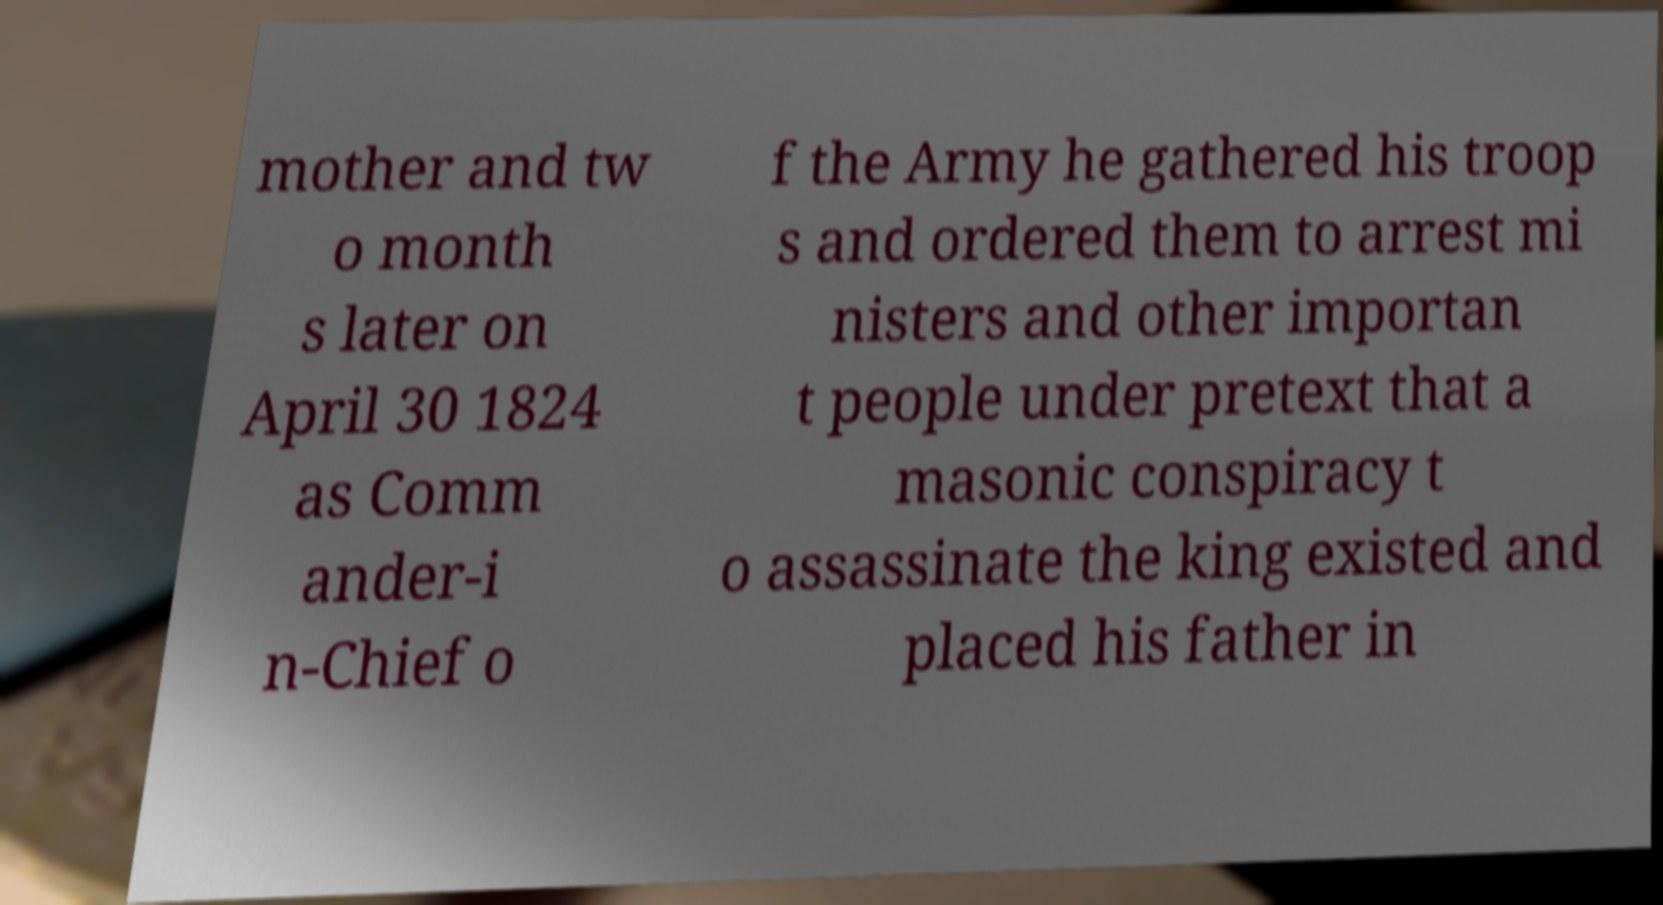What messages or text are displayed in this image? I need them in a readable, typed format. mother and tw o month s later on April 30 1824 as Comm ander-i n-Chief o f the Army he gathered his troop s and ordered them to arrest mi nisters and other importan t people under pretext that a masonic conspiracy t o assassinate the king existed and placed his father in 